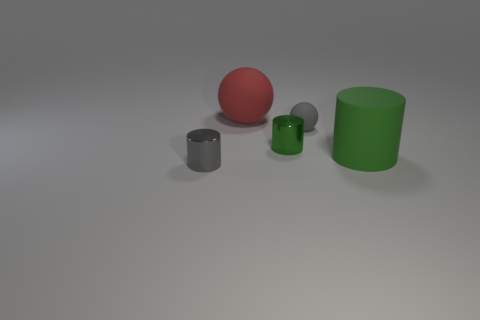What size is the matte thing that is the same shape as the tiny gray shiny thing?
Make the answer very short. Large. There is a small shiny thing to the right of the gray shiny cylinder; is its color the same as the rubber cylinder?
Your response must be concise. Yes. Is the number of matte balls less than the number of matte objects?
Give a very brief answer. Yes. What number of other objects are there of the same color as the rubber cylinder?
Provide a short and direct response. 1. Do the gray object behind the green metallic object and the large sphere have the same material?
Your response must be concise. Yes. What material is the gray object that is in front of the tiny rubber ball?
Keep it short and to the point. Metal. What size is the shiny cylinder in front of the big matte object that is to the right of the big red sphere?
Your answer should be very brief. Small. Are there any cylinders that have the same material as the red object?
Ensure brevity in your answer.  Yes. What is the shape of the big matte object that is left of the metallic object on the right side of the sphere on the left side of the gray rubber object?
Ensure brevity in your answer.  Sphere. There is a cylinder behind the large rubber cylinder; does it have the same color as the cylinder that is on the right side of the small green object?
Give a very brief answer. Yes. 